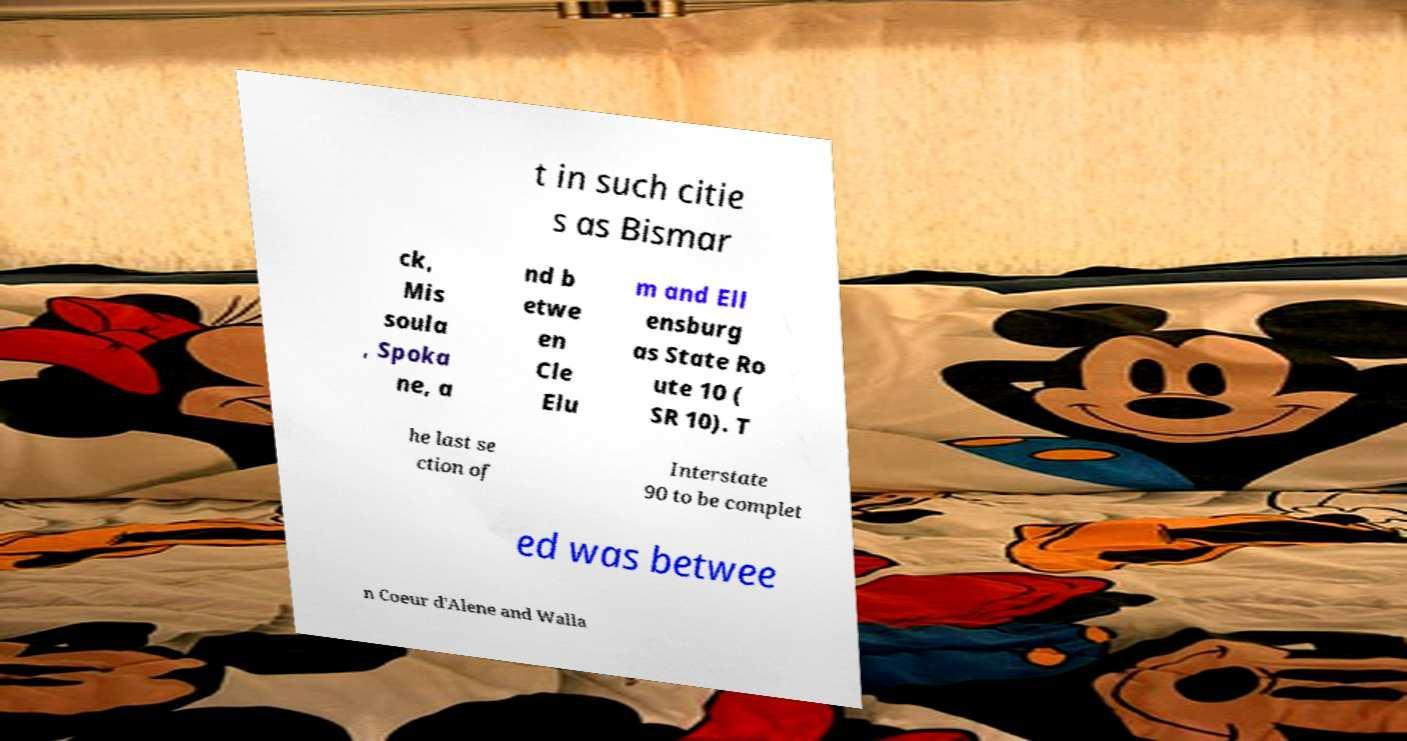Can you accurately transcribe the text from the provided image for me? t in such citie s as Bismar ck, Mis soula , Spoka ne, a nd b etwe en Cle Elu m and Ell ensburg as State Ro ute 10 ( SR 10). T he last se ction of Interstate 90 to be complet ed was betwee n Coeur d'Alene and Walla 